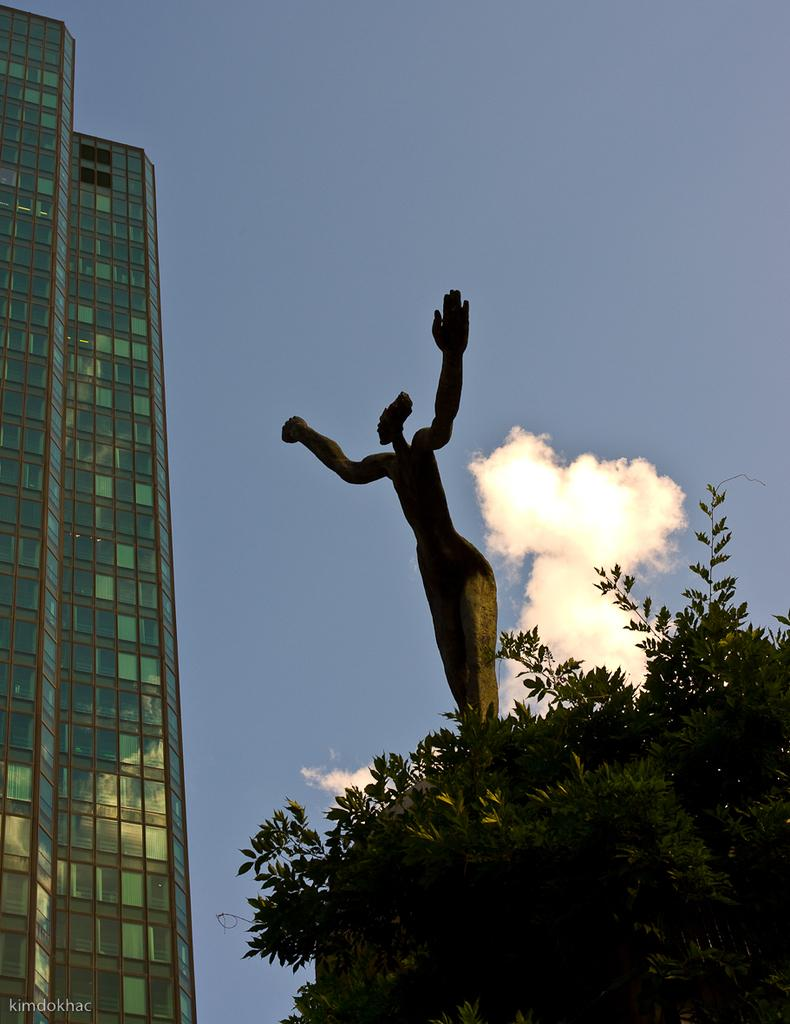What structure is located on the left side of the image? There is a building on the left side of the image. What type of object can be seen in the image besides the building? There is a statue and a tree in the image. What is visible at the top of the image? The sky is visible at the top of the image. What degree does the statue have in the image? There is no indication of a degree in the image, as it features a statue and not a person. Can you tell me how many elbows the tree has in the image? Trees do not have elbows, as they are not human or animal body parts. 